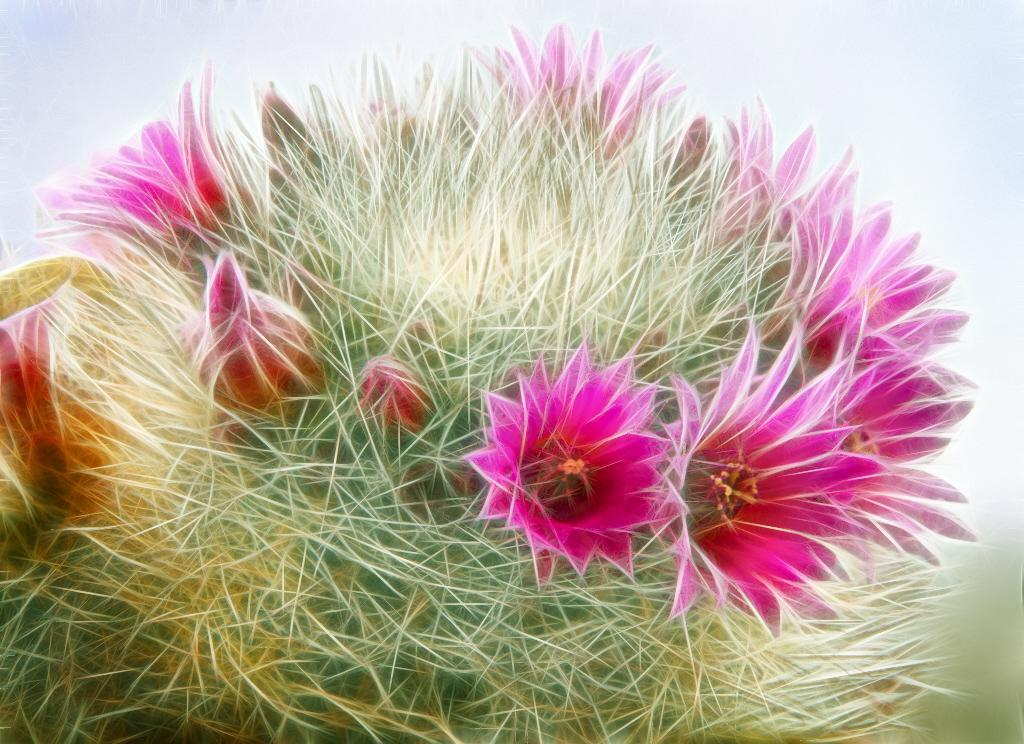What type of image is being described? The image is animated. What is depicted in the animated image? The animated image shows flowers and plants. What type of oatmeal is being served at the station in the image? There is no station or oatmeal present in the image; it is an animated image featuring flowers and plants. 